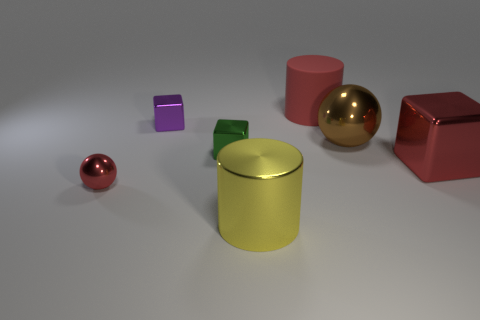Does the large rubber object have the same color as the small shiny sphere?
Provide a short and direct response. Yes. There is a big cylinder behind the big yellow cylinder; is it the same color as the large metal block?
Ensure brevity in your answer.  Yes. The purple shiny thing has what size?
Make the answer very short. Small. What is the size of the shiny sphere that is on the left side of the cylinder in front of the red metal sphere?
Your response must be concise. Small. How many large cylinders have the same color as the big shiny ball?
Ensure brevity in your answer.  0. How many large rubber cylinders are there?
Give a very brief answer. 1. What number of tiny cyan cubes are the same material as the green block?
Give a very brief answer. 0. What is the size of the other object that is the same shape as the big brown object?
Ensure brevity in your answer.  Small. What is the material of the small purple object?
Give a very brief answer. Metal. There is a big cylinder that is behind the small object in front of the green shiny thing in front of the small purple object; what is it made of?
Your answer should be very brief. Rubber. 